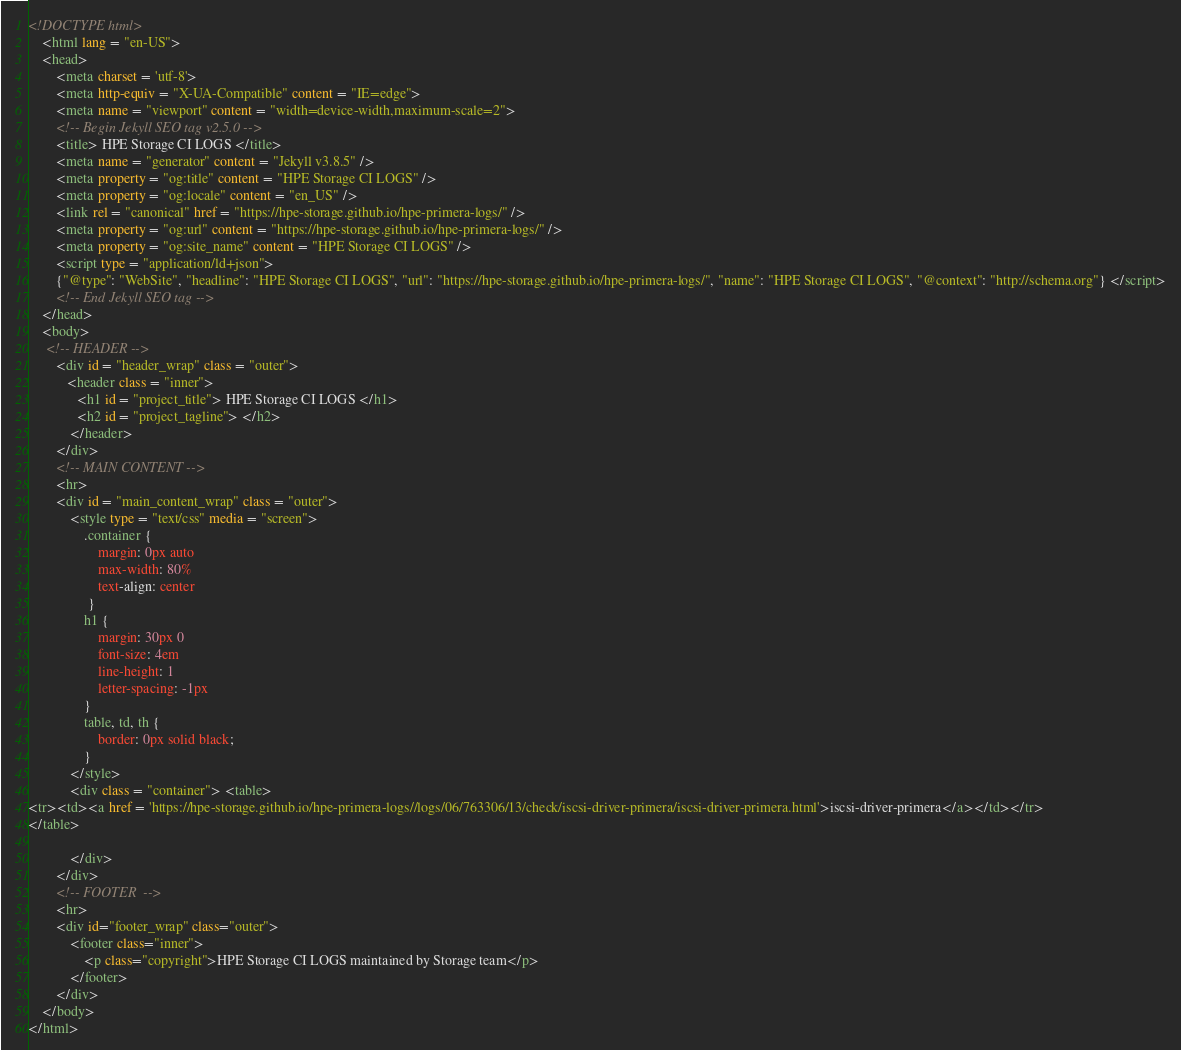Convert code to text. <code><loc_0><loc_0><loc_500><loc_500><_HTML_>
<!DOCTYPE html>
    <html lang = "en-US">
    <head>
        <meta charset = 'utf-8'>
        <meta http-equiv = "X-UA-Compatible" content = "IE=edge">
        <meta name = "viewport" content = "width=device-width,maximum-scale=2">
        <!-- Begin Jekyll SEO tag v2.5.0 -->
        <title> HPE Storage CI LOGS </title>
        <meta name = "generator" content = "Jekyll v3.8.5" />
        <meta property = "og:title" content = "HPE Storage CI LOGS" />
        <meta property = "og:locale" content = "en_US" />
        <link rel = "canonical" href = "https://hpe-storage.github.io/hpe-primera-logs/" />
        <meta property = "og:url" content = "https://hpe-storage.github.io/hpe-primera-logs/" />
        <meta property = "og:site_name" content = "HPE Storage CI LOGS" />
        <script type = "application/ld+json">
        {"@type": "WebSite", "headline": "HPE Storage CI LOGS", "url": "https://hpe-storage.github.io/hpe-primera-logs/", "name": "HPE Storage CI LOGS", "@context": "http://schema.org"} </script>
        <!-- End Jekyll SEO tag -->
    </head>
    <body>
     <!-- HEADER -->
        <div id = "header_wrap" class = "outer">
           <header class = "inner">
              <h1 id = "project_title"> HPE Storage CI LOGS </h1>
              <h2 id = "project_tagline"> </h2>
            </header>
        </div>
        <!-- MAIN CONTENT -->
        <hr>
        <div id = "main_content_wrap" class = "outer">
            <style type = "text/css" media = "screen">
                .container {
                    margin: 0px auto
                    max-width: 80%
                    text-align: center
                 }
                h1 {
                    margin: 30px 0
                    font-size: 4em
                    line-height: 1
                    letter-spacing: -1px
                }
                table, td, th {
                    border: 0px solid black;
                }
            </style>
            <div class = "container"> <table>
<tr><td><a href = 'https://hpe-storage.github.io/hpe-primera-logs//logs/06/763306/13/check/iscsi-driver-primera/iscsi-driver-primera.html'>iscsi-driver-primera</a></td></tr>
</table>

            </div>
        </div>
        <!-- FOOTER  -->
        <hr>
        <div id="footer_wrap" class="outer">
            <footer class="inner">
                <p class="copyright">HPE Storage CI LOGS maintained by Storage team</p>
            </footer>
        </div>
    </body>
</html>
</code> 